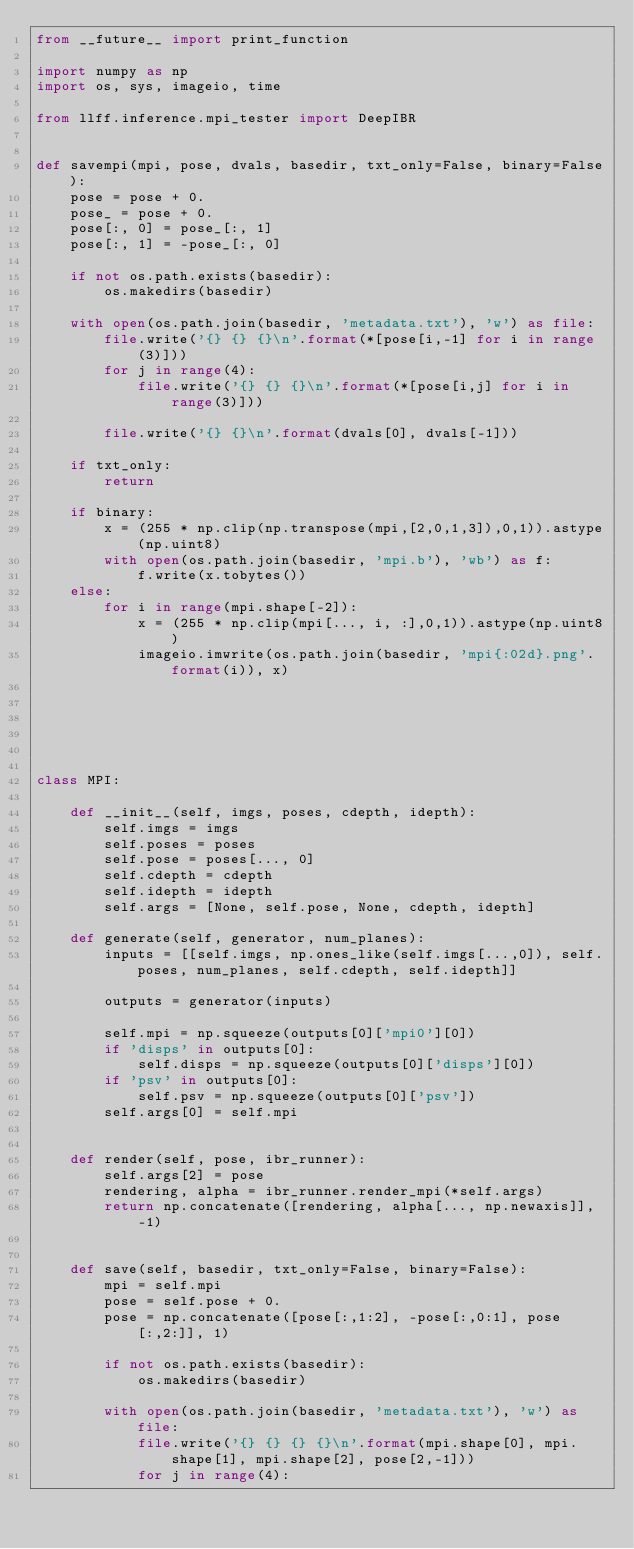Convert code to text. <code><loc_0><loc_0><loc_500><loc_500><_Python_>from __future__ import print_function

import numpy as np
import os, sys, imageio, time

from llff.inference.mpi_tester import DeepIBR
    

def savempi(mpi, pose, dvals, basedir, txt_only=False, binary=False):
    pose = pose + 0.
    pose_ = pose + 0.
    pose[:, 0] = pose_[:, 1]
    pose[:, 1] = -pose_[:, 0]
    
    if not os.path.exists(basedir):
        os.makedirs(basedir)

    with open(os.path.join(basedir, 'metadata.txt'), 'w') as file:
        file.write('{} {} {}\n'.format(*[pose[i,-1] for i in range(3)]))
        for j in range(4):
            file.write('{} {} {}\n'.format(*[pose[i,j] for i in range(3)]))
            
        file.write('{} {}\n'.format(dvals[0], dvals[-1]))
    
    if txt_only:
        return
    
    if binary:
        x = (255 * np.clip(np.transpose(mpi,[2,0,1,3]),0,1)).astype(np.uint8)
        with open(os.path.join(basedir, 'mpi.b'), 'wb') as f:
            f.write(x.tobytes())
    else:
        for i in range(mpi.shape[-2]):
            x = (255 * np.clip(mpi[..., i, :],0,1)).astype(np.uint8)
            imageio.imwrite(os.path.join(basedir, 'mpi{:02d}.png'.format(i)), x)
        
    
    
    


class MPI:
    
    def __init__(self, imgs, poses, cdepth, idepth):
        self.imgs = imgs
        self.poses = poses
        self.pose = poses[..., 0]
        self.cdepth = cdepth
        self.idepth = idepth
        self.args = [None, self.pose, None, cdepth, idepth]
        
    def generate(self, generator, num_planes):
        inputs = [[self.imgs, np.ones_like(self.imgs[...,0]), self.poses, num_planes, self.cdepth, self.idepth]]
        
        outputs = generator(inputs)
        
        self.mpi = np.squeeze(outputs[0]['mpi0'][0]) 
        if 'disps' in outputs[0]:
            self.disps = np.squeeze(outputs[0]['disps'][0])
        if 'psv' in outputs[0]:
            self.psv = np.squeeze(outputs[0]['psv'])
        self.args[0] = self.mpi
        
    
    def render(self, pose, ibr_runner):
        self.args[2] = pose
        rendering, alpha = ibr_runner.render_mpi(*self.args)
        return np.concatenate([rendering, alpha[..., np.newaxis]], -1)


    def save(self, basedir, txt_only=False, binary=False):
        mpi = self.mpi
        pose = self.pose + 0.
        pose = np.concatenate([pose[:,1:2], -pose[:,0:1], pose[:,2:]], 1)
        
        if not os.path.exists(basedir):
            os.makedirs(basedir)

        with open(os.path.join(basedir, 'metadata.txt'), 'w') as file:
            file.write('{} {} {} {}\n'.format(mpi.shape[0], mpi.shape[1], mpi.shape[2], pose[2,-1]))
            for j in range(4):</code> 